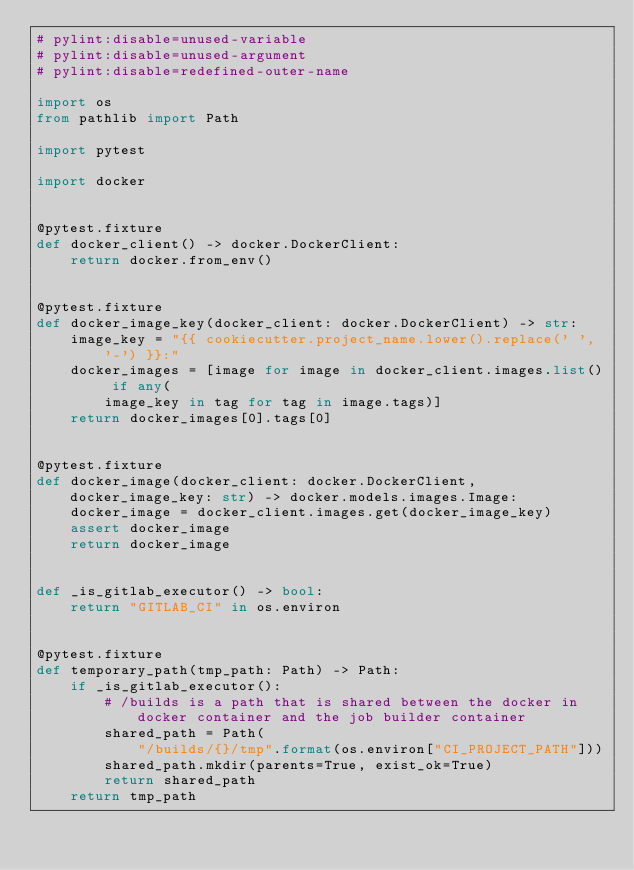Convert code to text. <code><loc_0><loc_0><loc_500><loc_500><_Python_># pylint:disable=unused-variable
# pylint:disable=unused-argument
# pylint:disable=redefined-outer-name

import os
from pathlib import Path

import pytest

import docker


@pytest.fixture
def docker_client() -> docker.DockerClient:
    return docker.from_env()


@pytest.fixture
def docker_image_key(docker_client: docker.DockerClient) -> str:
    image_key = "{{ cookiecutter.project_name.lower().replace(' ', '-') }}:"
    docker_images = [image for image in docker_client.images.list() if any(
        image_key in tag for tag in image.tags)]
    return docker_images[0].tags[0]


@pytest.fixture
def docker_image(docker_client: docker.DockerClient, docker_image_key: str) -> docker.models.images.Image:
    docker_image = docker_client.images.get(docker_image_key)
    assert docker_image
    return docker_image


def _is_gitlab_executor() -> bool:
    return "GITLAB_CI" in os.environ


@pytest.fixture
def temporary_path(tmp_path: Path) -> Path:
    if _is_gitlab_executor():
        # /builds is a path that is shared between the docker in docker container and the job builder container
        shared_path = Path(
            "/builds/{}/tmp".format(os.environ["CI_PROJECT_PATH"]))
        shared_path.mkdir(parents=True, exist_ok=True)
        return shared_path
    return tmp_path
</code> 